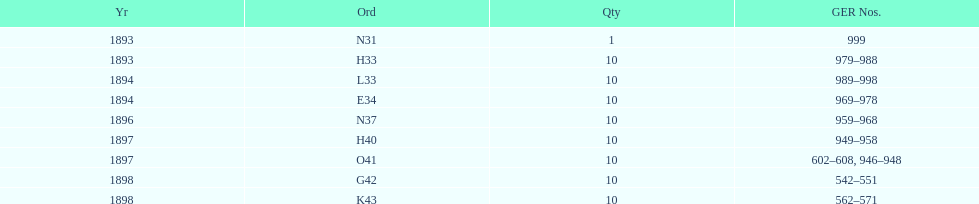When was g42, 1898 or 1894? 1898. 